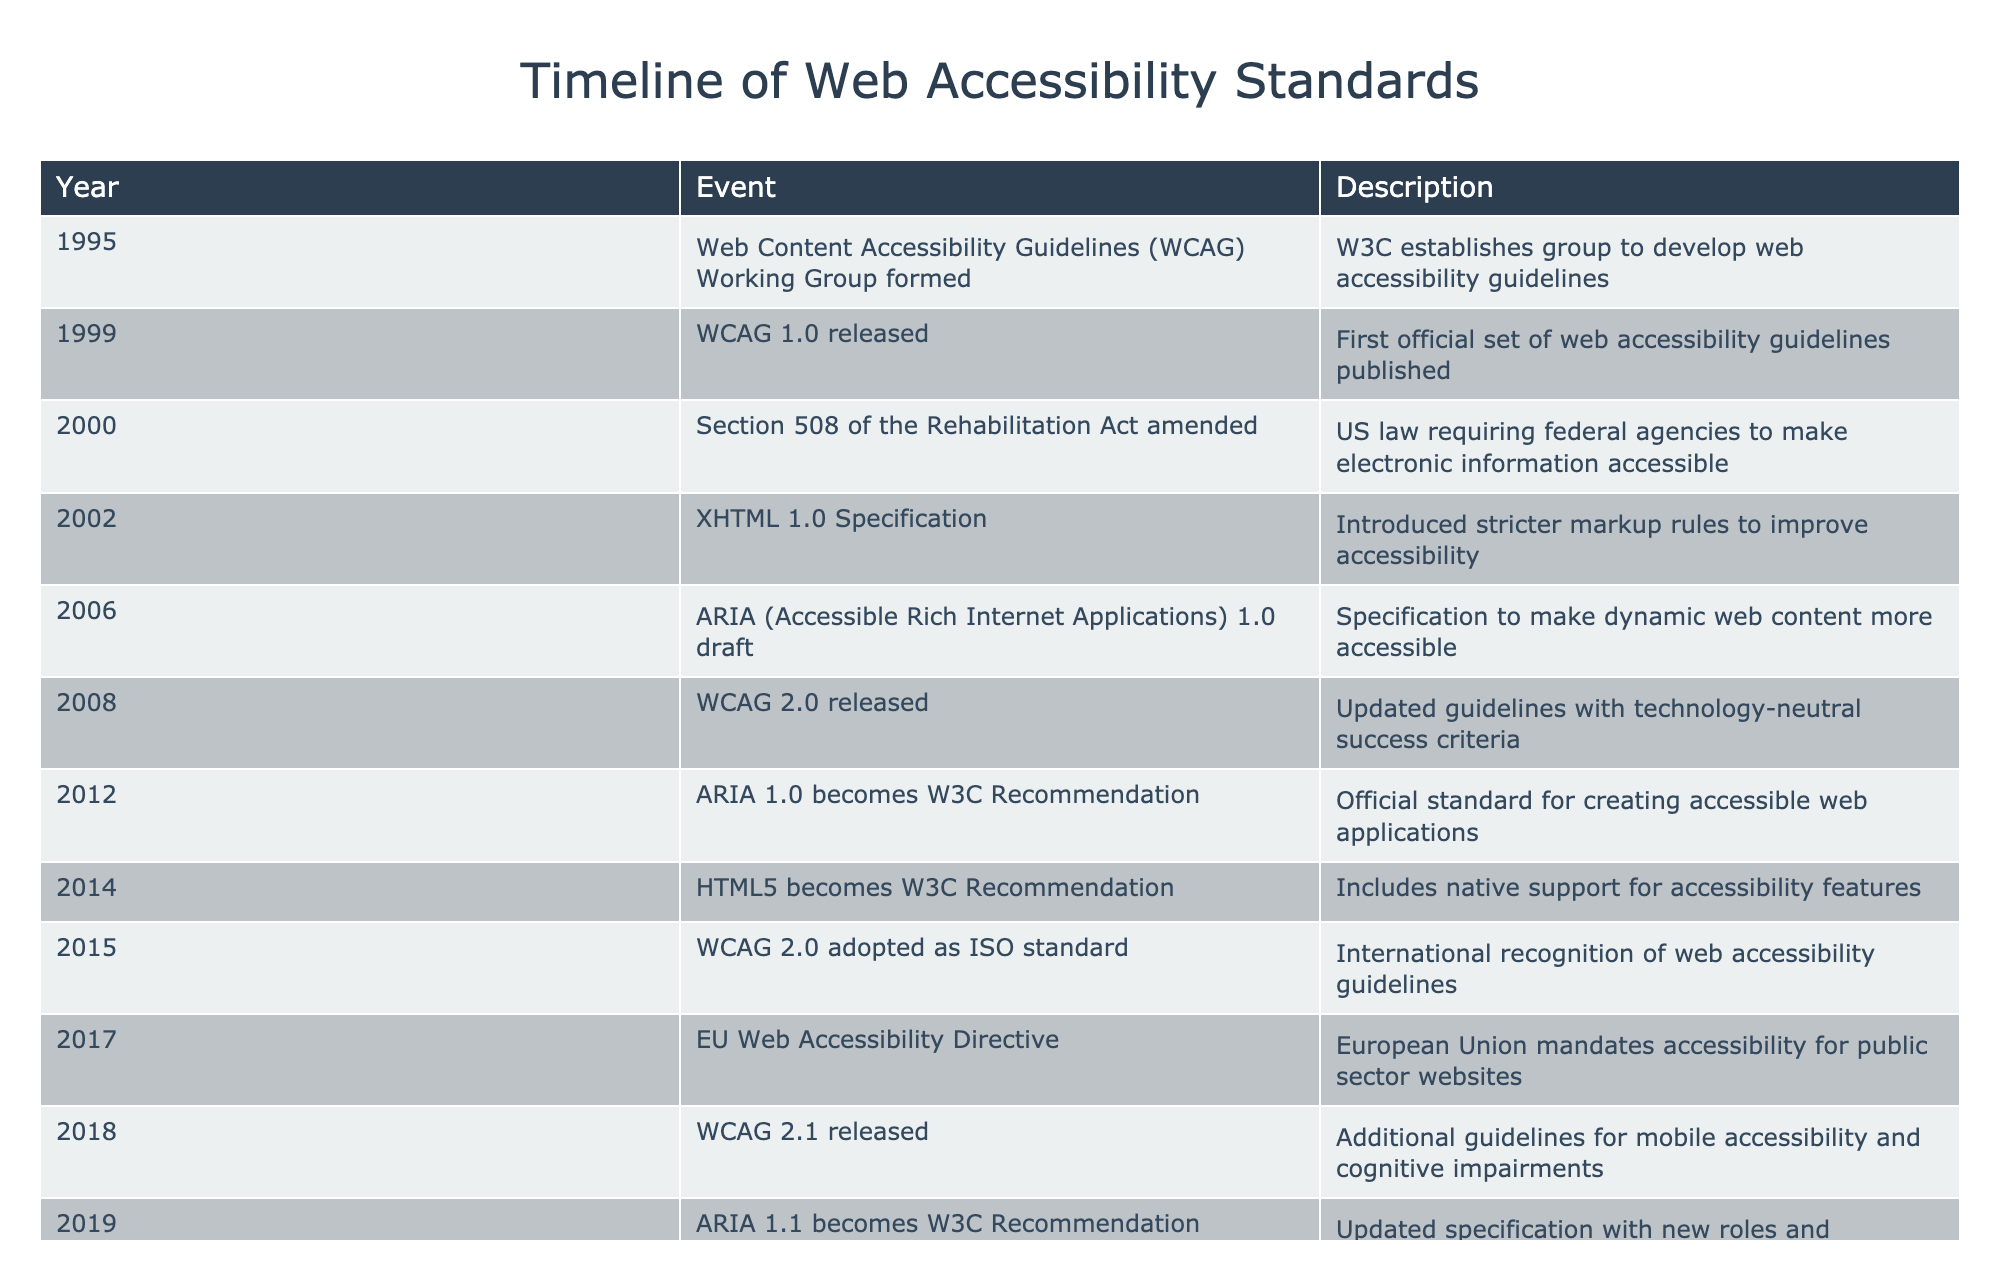What year was WCAG 2.0 released? According to the table, WCAG 2.0 was released in 2008. This can be directly found in the "Event" column that lists the release of WCAG 2.0.
Answer: 2008 What are the two significant changes in web accessibility standards that occurred in 2012 and 2014? In 2012, ARIA 1.0 became a W3C Recommendation, which set an official standard for creating accessible web applications. In 2014, HTML5 became a W3C Recommendation, which included native support for accessibility features. These events can be found in their respective rows.
Answer: ARIA 1.0 as W3C Recommendation in 2012 and HTML5 as W3C Recommendation in 2014 Which event happened first: the release of WCAG 1.0 or the amendment of Section 508 of the Rehabilitation Act? The amendment of Section 508 of the Rehabilitation Act occurred in the year 2000, while WCAG 1.0 was released in 1999. Comparing the years listed in the table, WCAG 1.0 occurred earlier.
Answer: WCAG 1.0 released first How many years passed between the release of WCAG 2.0 and the adoption of WCAG 2.0 as an ISO standard? WCAG 2.0 was released in 2008 and adopted as an ISO standard in 2015. To find the difference, subtract 2008 from 2015, which equals 7 years. This calculation is based on the "Year" values for those two events in the table.
Answer: 7 years Is the EU Web Accessibility Directive issued before or after WCAG 2.1? The EU Web Accessibility Directive was established in 2017, while WCAG 2.1 was released in 2018. By comparing these years in the table, we can conclude that the directive was issued before WCAG 2.1.
Answer: Before What is the total number of significant events listed in the table? By counting the entries in the table, we see there are 14 events from 1995 to 2023. This total can be calculated by counting the number of rows in the table.
Answer: 14 events Did any web accessibility guidelines become a W3C Recommendation twice, based on the events in the table? Yes, ARIA 1.0 became a W3C Recommendation in 2012 and then ARIA 1.1 became a W3C Recommendation in 2019. The table clearly indicates that ARIA has been recognized multiple times.
Answer: Yes Which set of guidelines was first recognized internationally, and what year was it adopted? WCAG 2.0 was the first set of guidelines to be adopted as an ISO standard in 2015, as noted in the table. The year can be found in the "Event" column under the respective entry.
Answer: WCAG 2.0 in 2015 What is the significance of the year 2023 in the timeline? The year 2023 marks the development of WCAG 3.0 as a Working Draft, indicating ongoing efforts to improve web accessibility standards. This can be noted in the last row of the table, which highlights future revisions.
Answer: Development of WCAG 3.0 as a Working Draft 